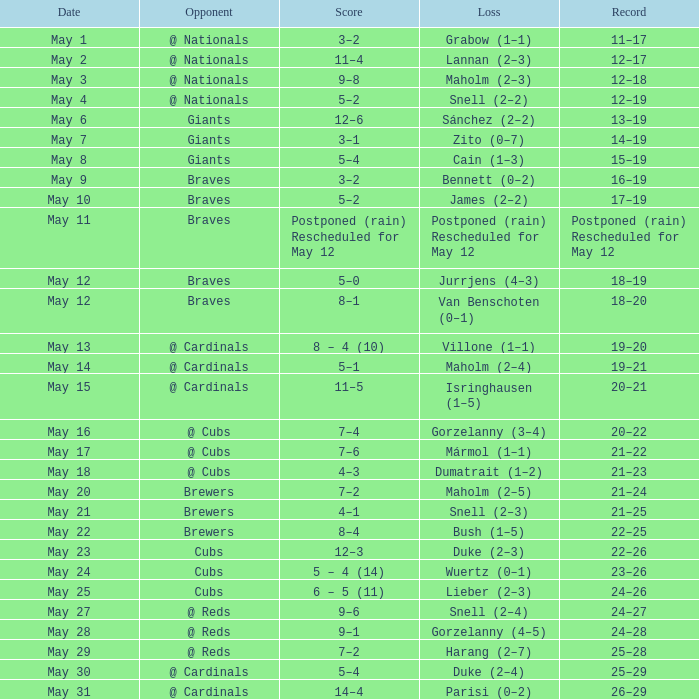What was the outcome of the game that had a 12-6 score? 13–19. 